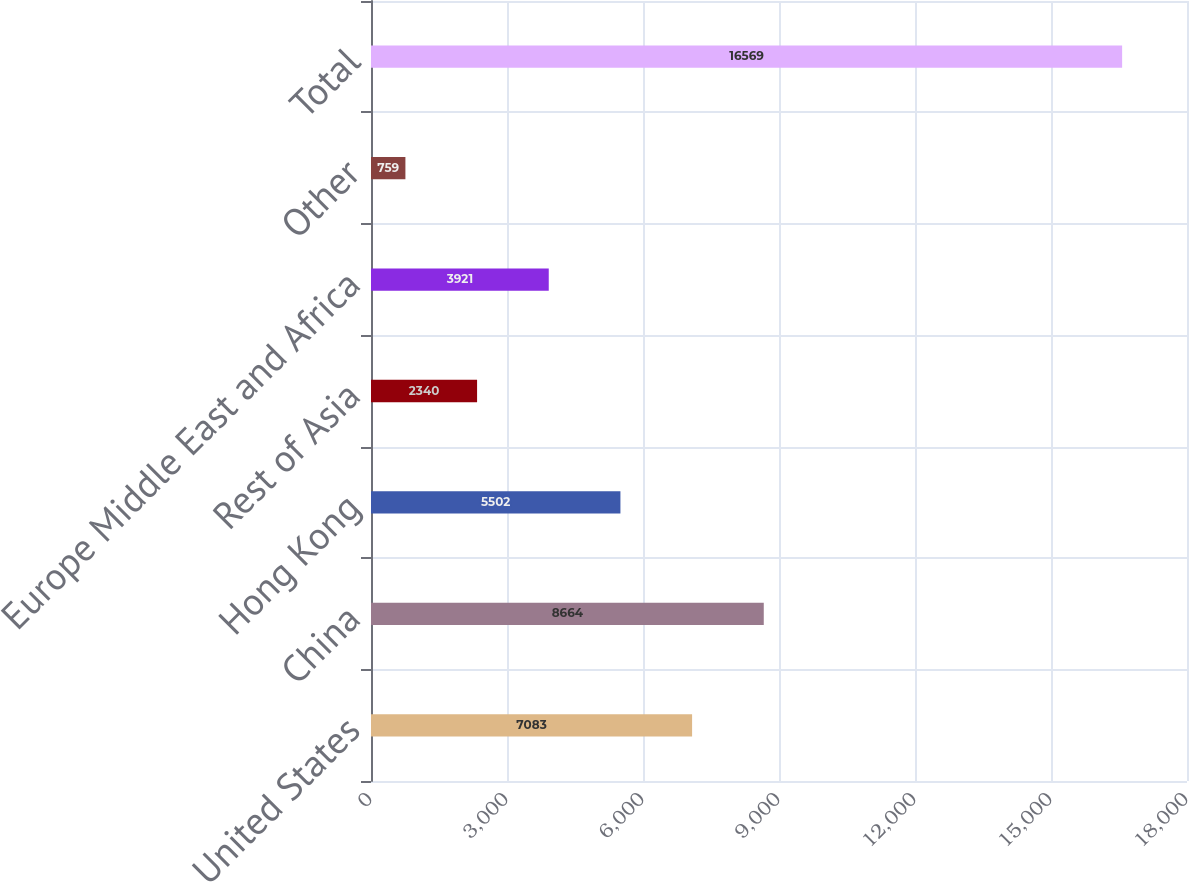Convert chart. <chart><loc_0><loc_0><loc_500><loc_500><bar_chart><fcel>United States<fcel>China<fcel>Hong Kong<fcel>Rest of Asia<fcel>Europe Middle East and Africa<fcel>Other<fcel>Total<nl><fcel>7083<fcel>8664<fcel>5502<fcel>2340<fcel>3921<fcel>759<fcel>16569<nl></chart> 